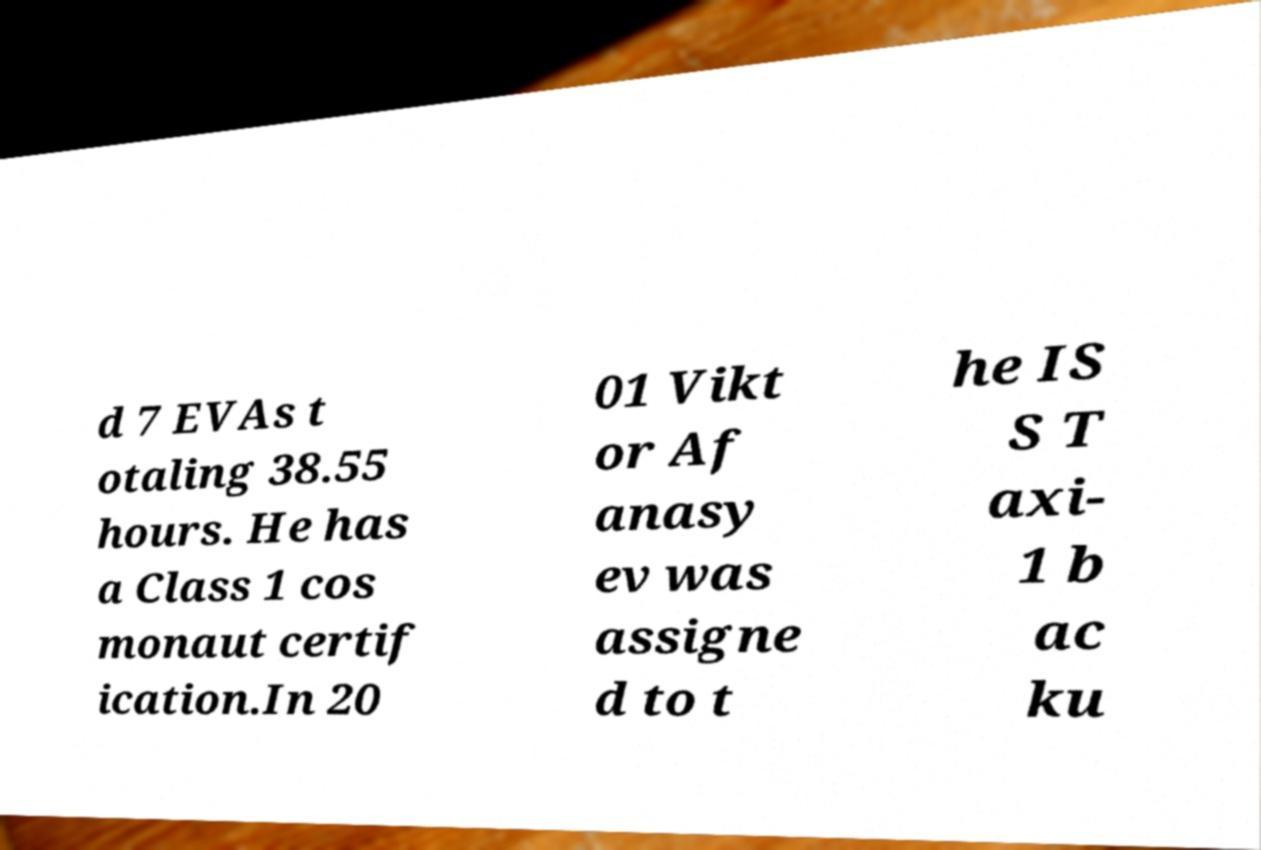Can you read and provide the text displayed in the image?This photo seems to have some interesting text. Can you extract and type it out for me? d 7 EVAs t otaling 38.55 hours. He has a Class 1 cos monaut certif ication.In 20 01 Vikt or Af anasy ev was assigne d to t he IS S T axi- 1 b ac ku 